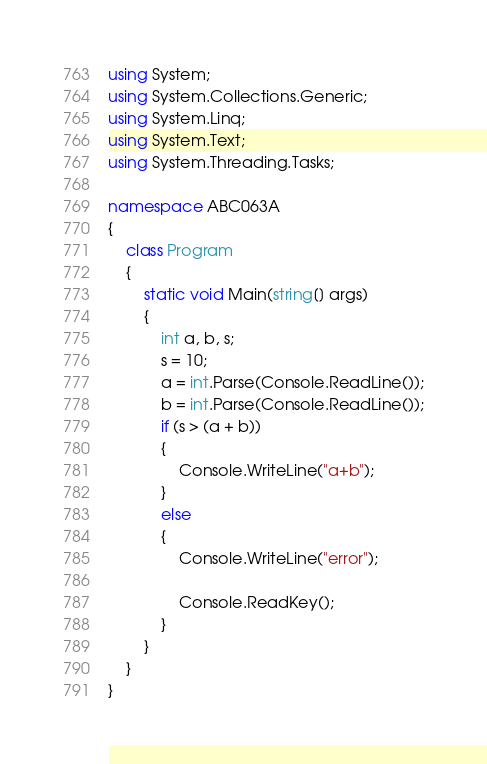<code> <loc_0><loc_0><loc_500><loc_500><_C#_>using System;
using System.Collections.Generic;
using System.Linq;
using System.Text;
using System.Threading.Tasks;

namespace ABC063A
{
	class Program
	{
		static void Main(string[] args)
		{
			int a, b, s;
			s = 10;
			a = int.Parse(Console.ReadLine());
			b = int.Parse(Console.ReadLine());
			if (s > (a + b))
			{
				Console.WriteLine("a+b");
			}
			else
			{
				Console.WriteLine("error");

				Console.ReadKey();
			}
		}
	}
}</code> 